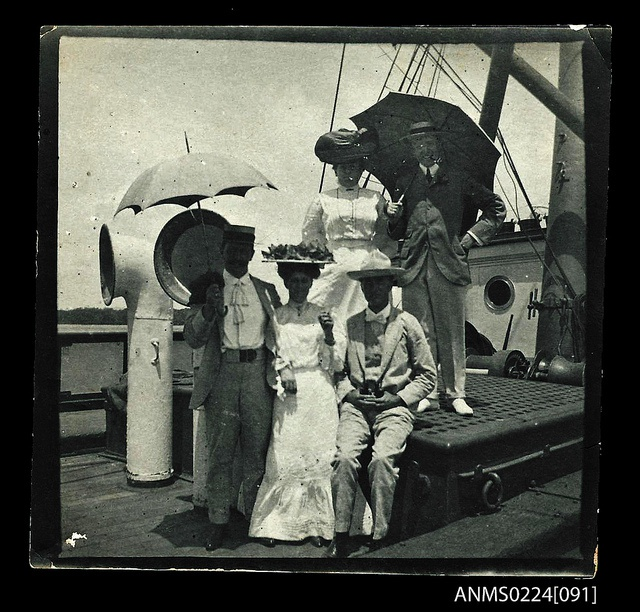Describe the objects in this image and their specific colors. I can see people in black, gray, and darkgray tones, people in black, beige, darkgray, lightgray, and gray tones, people in black, gray, and darkgray tones, people in black, darkgray, gray, and lightgray tones, and people in black, beige, gray, and darkgray tones in this image. 